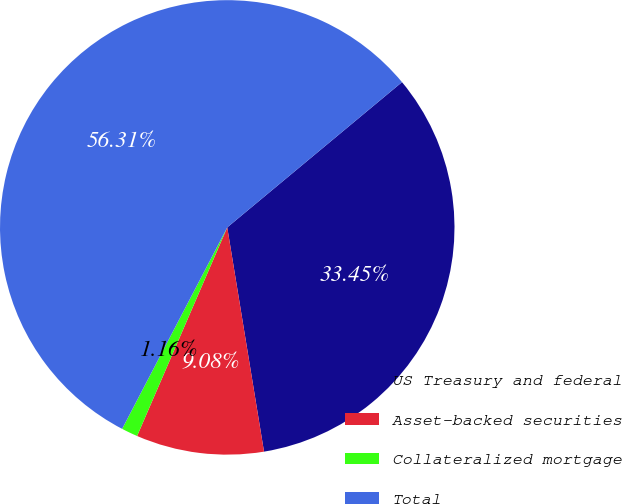Convert chart. <chart><loc_0><loc_0><loc_500><loc_500><pie_chart><fcel>US Treasury and federal<fcel>Asset-backed securities<fcel>Collateralized mortgage<fcel>Total<nl><fcel>33.45%<fcel>9.08%<fcel>1.16%<fcel>56.31%<nl></chart> 